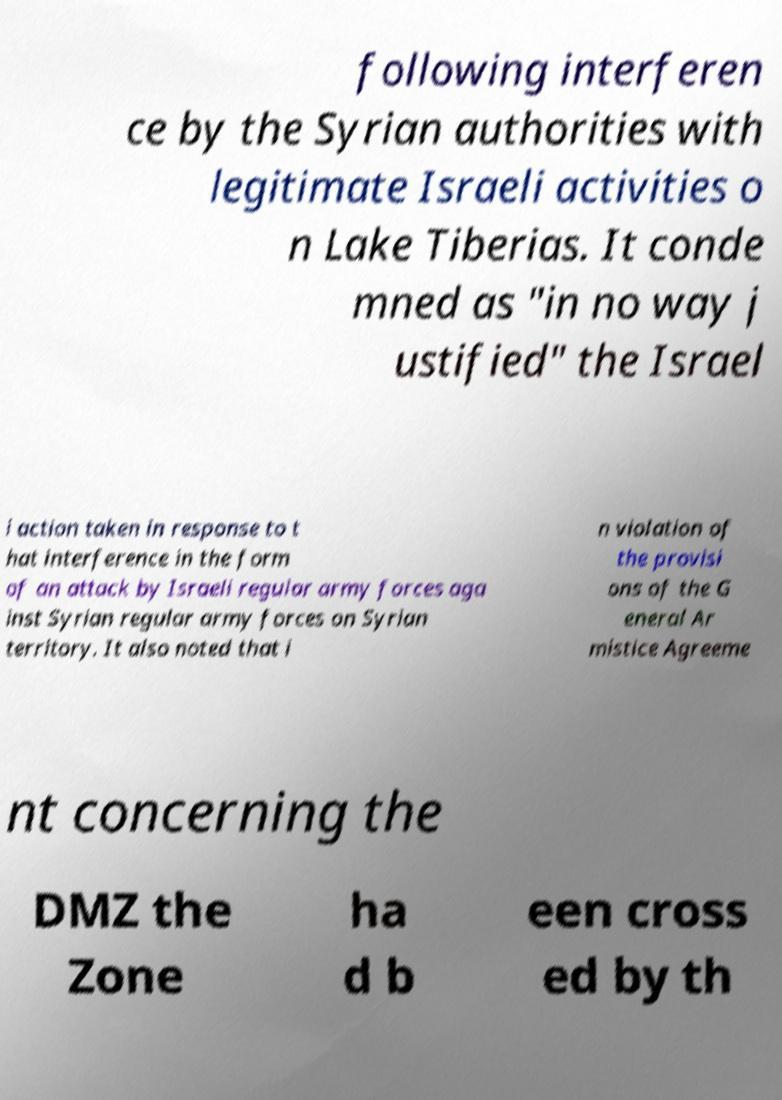There's text embedded in this image that I need extracted. Can you transcribe it verbatim? following interferen ce by the Syrian authorities with legitimate Israeli activities o n Lake Tiberias. It conde mned as "in no way j ustified" the Israel i action taken in response to t hat interference in the form of an attack by Israeli regular army forces aga inst Syrian regular army forces on Syrian territory. It also noted that i n violation of the provisi ons of the G eneral Ar mistice Agreeme nt concerning the DMZ the Zone ha d b een cross ed by th 